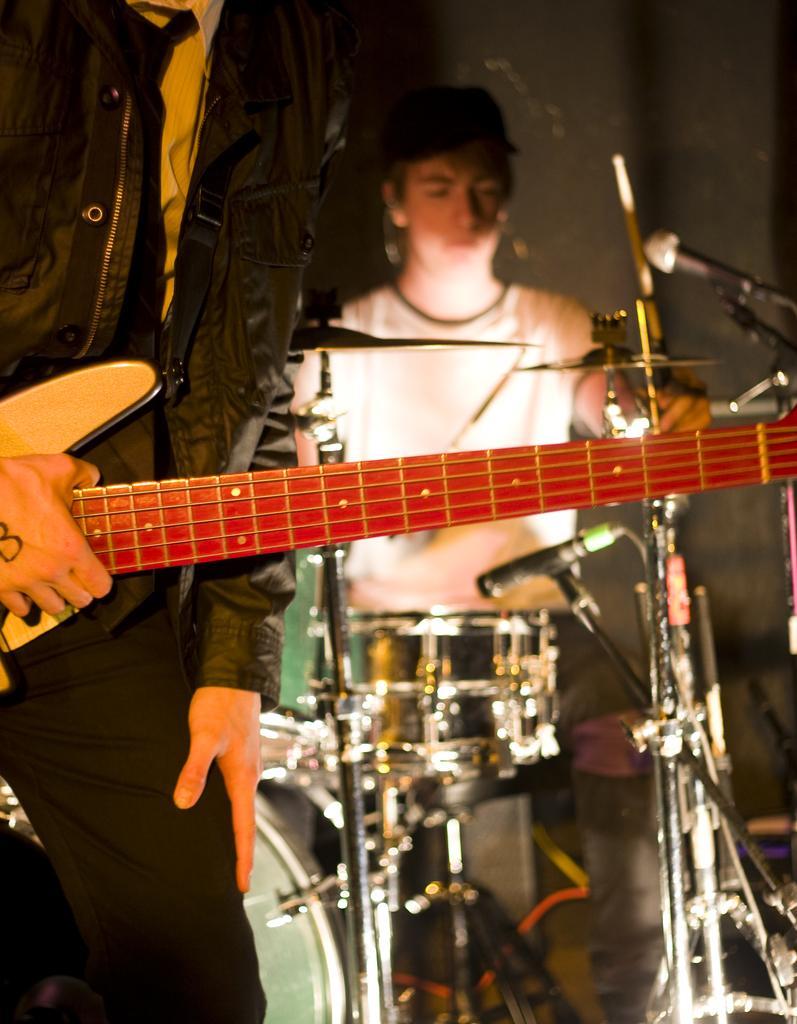Describe this image in one or two sentences. There is a person who is holding a guitar. Here we can see a person playing drums. This is mike. In the background there is a wall. 